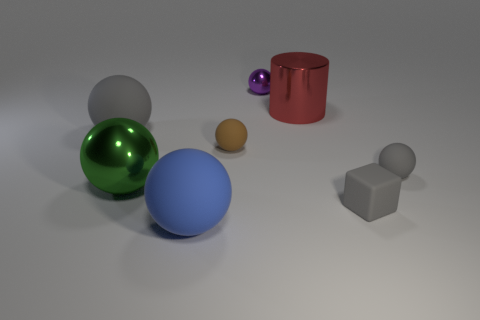Subtract all purple spheres. How many spheres are left? 5 Add 1 large red metallic things. How many objects exist? 9 Subtract all cyan cylinders. How many gray balls are left? 2 Subtract 4 spheres. How many spheres are left? 2 Subtract all gray balls. How many balls are left? 4 Subtract all blocks. How many objects are left? 7 Subtract all blue balls. Subtract all purple cubes. How many balls are left? 5 Subtract all tiny gray matte balls. Subtract all tiny objects. How many objects are left? 3 Add 3 large red objects. How many large red objects are left? 4 Add 6 big gray matte balls. How many big gray matte balls exist? 7 